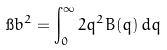Convert formula to latex. <formula><loc_0><loc_0><loc_500><loc_500>\i b ^ { 2 } = \int _ { 0 } ^ { \infty } { 2 q ^ { 2 } B ( q ) \, d q }</formula> 